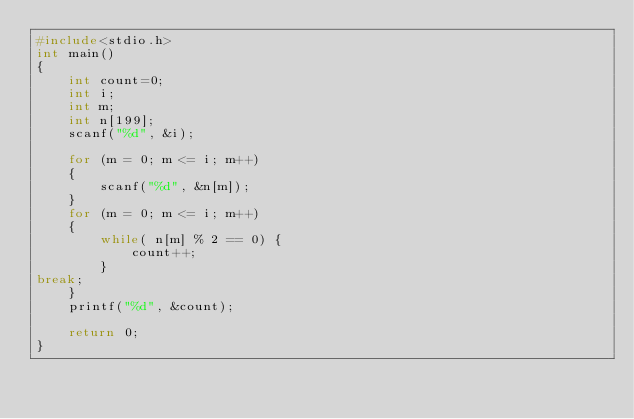Convert code to text. <code><loc_0><loc_0><loc_500><loc_500><_C_>#include<stdio.h>
int main()
{
	int count=0;
	int i;
	int m;
	int n[199];
	scanf("%d", &i);
	
	for (m = 0; m <= i; m++)
	{
		scanf("%d", &n[m]);
	}
	for (m = 0; m <= i; m++)
	{
		while( n[m] % 2 == 0) {
			count++;
		}
break;
	}
	printf("%d", &count);

    return 0;
}
</code> 